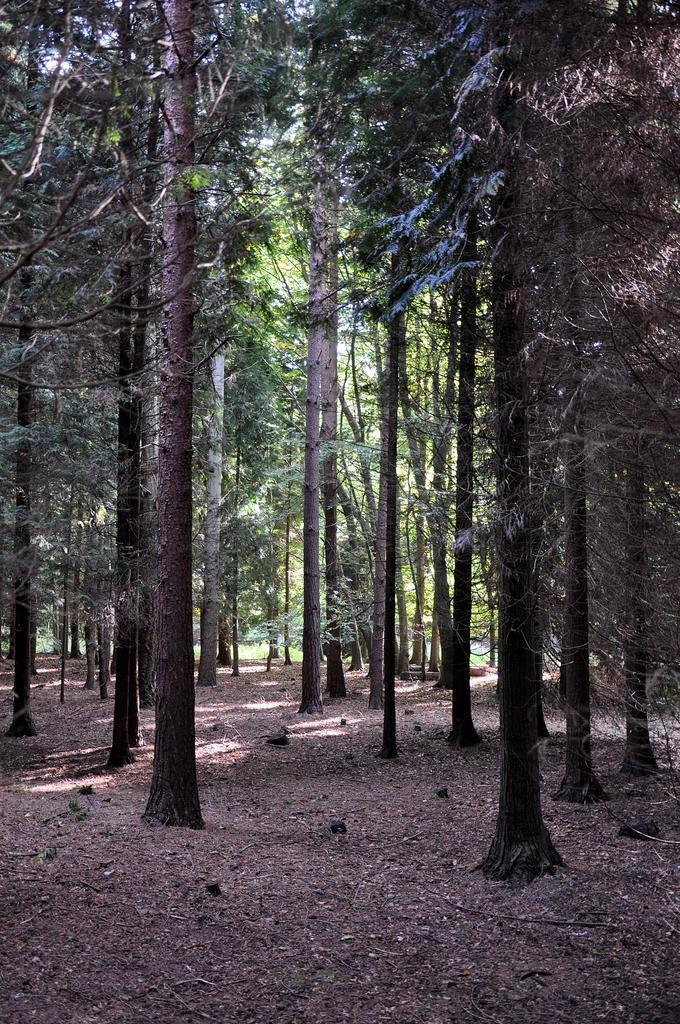What is present on the surface in the image? There is mud on the surface in the image. What type of vegetation can be seen in the image? There are trees in the image. How tall are the trees in the image? The trees in the image are tall. What type of juice is being squeezed from the trees in the image? There is no juice being squeezed from the trees in the image; the trees are simply tall and present in the image. 